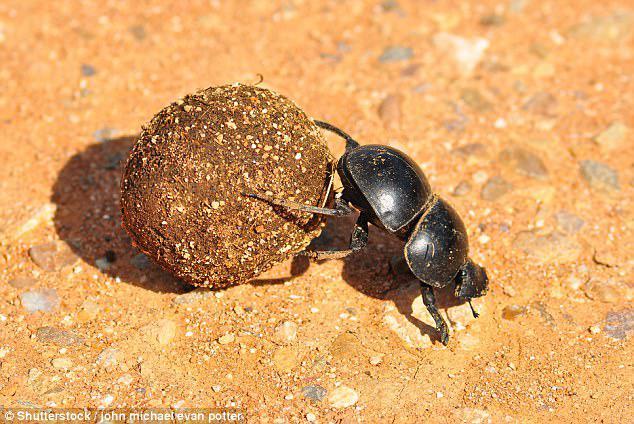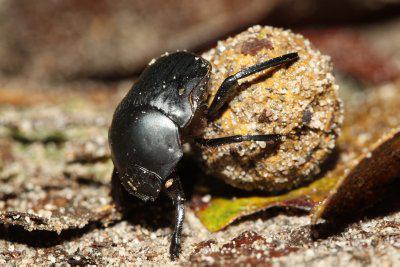The first image is the image on the left, the second image is the image on the right. Analyze the images presented: Is the assertion "Exactly one black beetle is shown in each image with its back appendages on a round rocky particle and at least one front appendage on the ground." valid? Answer yes or no. Yes. The first image is the image on the left, the second image is the image on the right. Analyze the images presented: Is the assertion "Each image shows exactly one beetle in contact with one round dung ball." valid? Answer yes or no. Yes. 